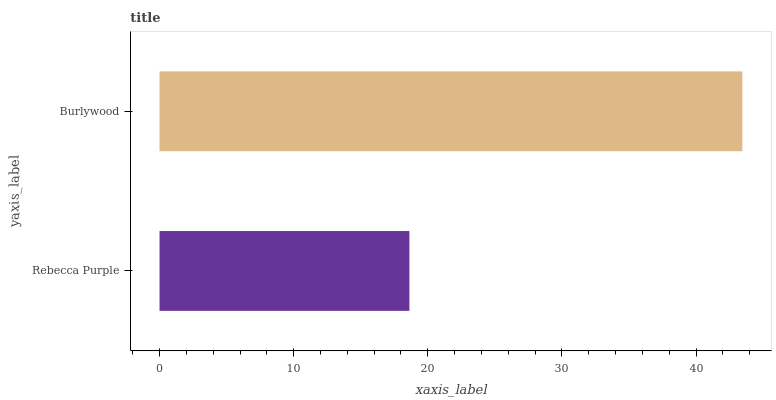Is Rebecca Purple the minimum?
Answer yes or no. Yes. Is Burlywood the maximum?
Answer yes or no. Yes. Is Burlywood the minimum?
Answer yes or no. No. Is Burlywood greater than Rebecca Purple?
Answer yes or no. Yes. Is Rebecca Purple less than Burlywood?
Answer yes or no. Yes. Is Rebecca Purple greater than Burlywood?
Answer yes or no. No. Is Burlywood less than Rebecca Purple?
Answer yes or no. No. Is Burlywood the high median?
Answer yes or no. Yes. Is Rebecca Purple the low median?
Answer yes or no. Yes. Is Rebecca Purple the high median?
Answer yes or no. No. Is Burlywood the low median?
Answer yes or no. No. 